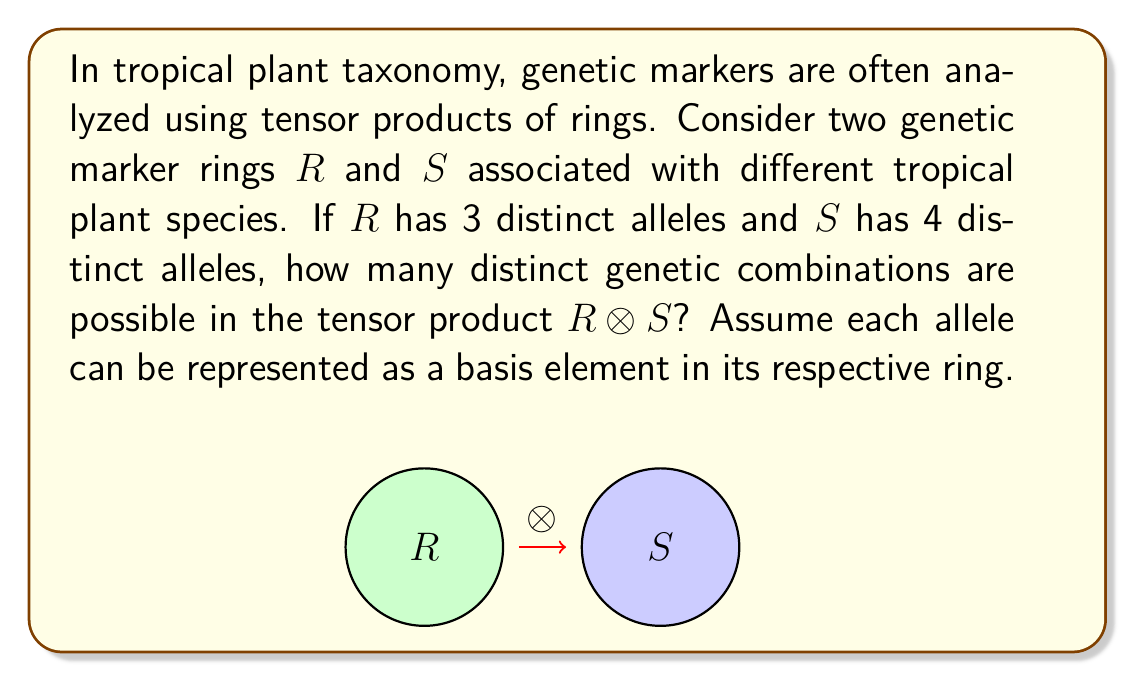What is the answer to this math problem? Let's approach this step-by-step:

1) In ring theory, the tensor product $R \otimes S$ of two rings $R$ and $S$ is itself a ring.

2) The basis elements of $R \otimes S$ are formed by taking all possible pairs of basis elements from $R$ and $S$.

3) In this case:
   - $R$ has 3 distinct alleles, which we can represent as basis elements $\{r_1, r_2, r_3\}$
   - $S$ has 4 distinct alleles, which we can represent as basis elements $\{s_1, s_2, s_3, s_4\}$

4) The basis elements of $R \otimes S$ will be all possible combinations of the form $r_i \otimes s_j$ where $i = 1, 2, 3$ and $j = 1, 2, 3, 4$.

5) To count the number of distinct combinations, we multiply the number of basis elements in each ring:

   $$\text{Number of combinations} = |R| \times |S| = 3 \times 4 = 12$$

6) Therefore, the tensor product $R \otimes S$ will have 12 distinct basis elements, representing 12 possible genetic combinations.

This result showcases how tensor products can be used to model the combinatorial nature of genetic markers in tropical plant taxonomy, providing a mathematical framework for analyzing complex genetic relationships.
Answer: 12 distinct genetic combinations 